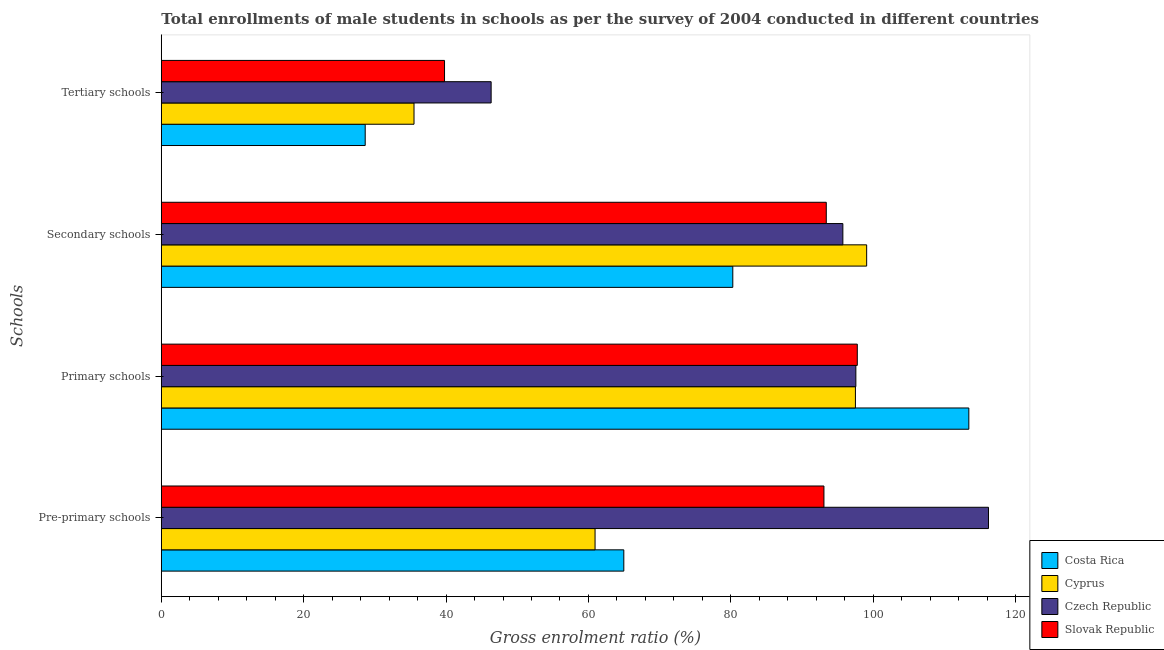Are the number of bars on each tick of the Y-axis equal?
Offer a terse response. Yes. How many bars are there on the 3rd tick from the top?
Provide a succinct answer. 4. What is the label of the 4th group of bars from the top?
Keep it short and to the point. Pre-primary schools. What is the gross enrolment ratio(male) in pre-primary schools in Cyprus?
Provide a short and direct response. 60.93. Across all countries, what is the maximum gross enrolment ratio(male) in tertiary schools?
Offer a very short reply. 46.33. Across all countries, what is the minimum gross enrolment ratio(male) in pre-primary schools?
Provide a short and direct response. 60.93. In which country was the gross enrolment ratio(male) in pre-primary schools minimum?
Your answer should be very brief. Cyprus. What is the total gross enrolment ratio(male) in tertiary schools in the graph?
Make the answer very short. 150.24. What is the difference between the gross enrolment ratio(male) in pre-primary schools in Cyprus and that in Slovak Republic?
Offer a very short reply. -32.15. What is the difference between the gross enrolment ratio(male) in secondary schools in Cyprus and the gross enrolment ratio(male) in primary schools in Czech Republic?
Your answer should be compact. 1.52. What is the average gross enrolment ratio(male) in secondary schools per country?
Give a very brief answer. 92.12. What is the difference between the gross enrolment ratio(male) in secondary schools and gross enrolment ratio(male) in pre-primary schools in Cyprus?
Provide a succinct answer. 38.15. What is the ratio of the gross enrolment ratio(male) in pre-primary schools in Czech Republic to that in Slovak Republic?
Your response must be concise. 1.25. Is the gross enrolment ratio(male) in primary schools in Slovak Republic less than that in Czech Republic?
Provide a succinct answer. No. What is the difference between the highest and the second highest gross enrolment ratio(male) in secondary schools?
Make the answer very short. 3.34. What is the difference between the highest and the lowest gross enrolment ratio(male) in tertiary schools?
Ensure brevity in your answer.  17.69. In how many countries, is the gross enrolment ratio(male) in pre-primary schools greater than the average gross enrolment ratio(male) in pre-primary schools taken over all countries?
Your answer should be compact. 2. Is the sum of the gross enrolment ratio(male) in secondary schools in Cyprus and Czech Republic greater than the maximum gross enrolment ratio(male) in pre-primary schools across all countries?
Your answer should be compact. Yes. What does the 2nd bar from the top in Tertiary schools represents?
Keep it short and to the point. Czech Republic. What does the 3rd bar from the bottom in Tertiary schools represents?
Make the answer very short. Czech Republic. Are all the bars in the graph horizontal?
Your answer should be compact. Yes. What is the difference between two consecutive major ticks on the X-axis?
Your answer should be very brief. 20. Are the values on the major ticks of X-axis written in scientific E-notation?
Offer a very short reply. No. How are the legend labels stacked?
Ensure brevity in your answer.  Vertical. What is the title of the graph?
Offer a terse response. Total enrollments of male students in schools as per the survey of 2004 conducted in different countries. What is the label or title of the X-axis?
Provide a short and direct response. Gross enrolment ratio (%). What is the label or title of the Y-axis?
Your answer should be very brief. Schools. What is the Gross enrolment ratio (%) in Costa Rica in Pre-primary schools?
Your answer should be very brief. 64.96. What is the Gross enrolment ratio (%) in Cyprus in Pre-primary schools?
Give a very brief answer. 60.93. What is the Gross enrolment ratio (%) in Czech Republic in Pre-primary schools?
Make the answer very short. 116.19. What is the Gross enrolment ratio (%) in Slovak Republic in Pre-primary schools?
Make the answer very short. 93.08. What is the Gross enrolment ratio (%) of Costa Rica in Primary schools?
Make the answer very short. 113.43. What is the Gross enrolment ratio (%) in Cyprus in Primary schools?
Ensure brevity in your answer.  97.5. What is the Gross enrolment ratio (%) in Czech Republic in Primary schools?
Your response must be concise. 97.56. What is the Gross enrolment ratio (%) in Slovak Republic in Primary schools?
Provide a short and direct response. 97.76. What is the Gross enrolment ratio (%) of Costa Rica in Secondary schools?
Your answer should be very brief. 80.27. What is the Gross enrolment ratio (%) of Cyprus in Secondary schools?
Provide a short and direct response. 99.08. What is the Gross enrolment ratio (%) in Czech Republic in Secondary schools?
Make the answer very short. 95.73. What is the Gross enrolment ratio (%) in Slovak Republic in Secondary schools?
Offer a very short reply. 93.41. What is the Gross enrolment ratio (%) in Costa Rica in Tertiary schools?
Make the answer very short. 28.64. What is the Gross enrolment ratio (%) of Cyprus in Tertiary schools?
Give a very brief answer. 35.49. What is the Gross enrolment ratio (%) of Czech Republic in Tertiary schools?
Provide a short and direct response. 46.33. What is the Gross enrolment ratio (%) of Slovak Republic in Tertiary schools?
Make the answer very short. 39.78. Across all Schools, what is the maximum Gross enrolment ratio (%) in Costa Rica?
Provide a short and direct response. 113.43. Across all Schools, what is the maximum Gross enrolment ratio (%) in Cyprus?
Offer a very short reply. 99.08. Across all Schools, what is the maximum Gross enrolment ratio (%) in Czech Republic?
Give a very brief answer. 116.19. Across all Schools, what is the maximum Gross enrolment ratio (%) of Slovak Republic?
Your response must be concise. 97.76. Across all Schools, what is the minimum Gross enrolment ratio (%) in Costa Rica?
Offer a terse response. 28.64. Across all Schools, what is the minimum Gross enrolment ratio (%) of Cyprus?
Provide a succinct answer. 35.49. Across all Schools, what is the minimum Gross enrolment ratio (%) of Czech Republic?
Offer a very short reply. 46.33. Across all Schools, what is the minimum Gross enrolment ratio (%) in Slovak Republic?
Provide a short and direct response. 39.78. What is the total Gross enrolment ratio (%) of Costa Rica in the graph?
Offer a terse response. 287.31. What is the total Gross enrolment ratio (%) in Cyprus in the graph?
Provide a short and direct response. 293. What is the total Gross enrolment ratio (%) in Czech Republic in the graph?
Provide a succinct answer. 355.81. What is the total Gross enrolment ratio (%) in Slovak Republic in the graph?
Offer a terse response. 324.02. What is the difference between the Gross enrolment ratio (%) of Costa Rica in Pre-primary schools and that in Primary schools?
Give a very brief answer. -48.46. What is the difference between the Gross enrolment ratio (%) of Cyprus in Pre-primary schools and that in Primary schools?
Your answer should be very brief. -36.57. What is the difference between the Gross enrolment ratio (%) in Czech Republic in Pre-primary schools and that in Primary schools?
Offer a terse response. 18.63. What is the difference between the Gross enrolment ratio (%) of Slovak Republic in Pre-primary schools and that in Primary schools?
Provide a short and direct response. -4.68. What is the difference between the Gross enrolment ratio (%) of Costa Rica in Pre-primary schools and that in Secondary schools?
Give a very brief answer. -15.31. What is the difference between the Gross enrolment ratio (%) in Cyprus in Pre-primary schools and that in Secondary schools?
Your answer should be very brief. -38.15. What is the difference between the Gross enrolment ratio (%) of Czech Republic in Pre-primary schools and that in Secondary schools?
Provide a succinct answer. 20.46. What is the difference between the Gross enrolment ratio (%) of Slovak Republic in Pre-primary schools and that in Secondary schools?
Make the answer very short. -0.33. What is the difference between the Gross enrolment ratio (%) in Costa Rica in Pre-primary schools and that in Tertiary schools?
Offer a very short reply. 36.33. What is the difference between the Gross enrolment ratio (%) of Cyprus in Pre-primary schools and that in Tertiary schools?
Provide a succinct answer. 25.43. What is the difference between the Gross enrolment ratio (%) in Czech Republic in Pre-primary schools and that in Tertiary schools?
Offer a very short reply. 69.86. What is the difference between the Gross enrolment ratio (%) in Slovak Republic in Pre-primary schools and that in Tertiary schools?
Provide a short and direct response. 53.29. What is the difference between the Gross enrolment ratio (%) in Costa Rica in Primary schools and that in Secondary schools?
Your answer should be compact. 33.15. What is the difference between the Gross enrolment ratio (%) in Cyprus in Primary schools and that in Secondary schools?
Provide a succinct answer. -1.58. What is the difference between the Gross enrolment ratio (%) in Czech Republic in Primary schools and that in Secondary schools?
Offer a terse response. 1.83. What is the difference between the Gross enrolment ratio (%) in Slovak Republic in Primary schools and that in Secondary schools?
Make the answer very short. 4.36. What is the difference between the Gross enrolment ratio (%) in Costa Rica in Primary schools and that in Tertiary schools?
Ensure brevity in your answer.  84.79. What is the difference between the Gross enrolment ratio (%) in Cyprus in Primary schools and that in Tertiary schools?
Keep it short and to the point. 62. What is the difference between the Gross enrolment ratio (%) of Czech Republic in Primary schools and that in Tertiary schools?
Provide a short and direct response. 51.23. What is the difference between the Gross enrolment ratio (%) in Slovak Republic in Primary schools and that in Tertiary schools?
Your response must be concise. 57.98. What is the difference between the Gross enrolment ratio (%) of Costa Rica in Secondary schools and that in Tertiary schools?
Ensure brevity in your answer.  51.63. What is the difference between the Gross enrolment ratio (%) in Cyprus in Secondary schools and that in Tertiary schools?
Keep it short and to the point. 63.58. What is the difference between the Gross enrolment ratio (%) of Czech Republic in Secondary schools and that in Tertiary schools?
Your answer should be compact. 49.4. What is the difference between the Gross enrolment ratio (%) in Slovak Republic in Secondary schools and that in Tertiary schools?
Ensure brevity in your answer.  53.62. What is the difference between the Gross enrolment ratio (%) of Costa Rica in Pre-primary schools and the Gross enrolment ratio (%) of Cyprus in Primary schools?
Your answer should be very brief. -32.53. What is the difference between the Gross enrolment ratio (%) in Costa Rica in Pre-primary schools and the Gross enrolment ratio (%) in Czech Republic in Primary schools?
Ensure brevity in your answer.  -32.59. What is the difference between the Gross enrolment ratio (%) in Costa Rica in Pre-primary schools and the Gross enrolment ratio (%) in Slovak Republic in Primary schools?
Provide a succinct answer. -32.8. What is the difference between the Gross enrolment ratio (%) of Cyprus in Pre-primary schools and the Gross enrolment ratio (%) of Czech Republic in Primary schools?
Your answer should be very brief. -36.63. What is the difference between the Gross enrolment ratio (%) in Cyprus in Pre-primary schools and the Gross enrolment ratio (%) in Slovak Republic in Primary schools?
Your response must be concise. -36.83. What is the difference between the Gross enrolment ratio (%) in Czech Republic in Pre-primary schools and the Gross enrolment ratio (%) in Slovak Republic in Primary schools?
Your response must be concise. 18.43. What is the difference between the Gross enrolment ratio (%) in Costa Rica in Pre-primary schools and the Gross enrolment ratio (%) in Cyprus in Secondary schools?
Ensure brevity in your answer.  -34.11. What is the difference between the Gross enrolment ratio (%) of Costa Rica in Pre-primary schools and the Gross enrolment ratio (%) of Czech Republic in Secondary schools?
Provide a succinct answer. -30.77. What is the difference between the Gross enrolment ratio (%) of Costa Rica in Pre-primary schools and the Gross enrolment ratio (%) of Slovak Republic in Secondary schools?
Your answer should be very brief. -28.44. What is the difference between the Gross enrolment ratio (%) of Cyprus in Pre-primary schools and the Gross enrolment ratio (%) of Czech Republic in Secondary schools?
Your answer should be compact. -34.81. What is the difference between the Gross enrolment ratio (%) in Cyprus in Pre-primary schools and the Gross enrolment ratio (%) in Slovak Republic in Secondary schools?
Your response must be concise. -32.48. What is the difference between the Gross enrolment ratio (%) of Czech Republic in Pre-primary schools and the Gross enrolment ratio (%) of Slovak Republic in Secondary schools?
Make the answer very short. 22.78. What is the difference between the Gross enrolment ratio (%) in Costa Rica in Pre-primary schools and the Gross enrolment ratio (%) in Cyprus in Tertiary schools?
Provide a succinct answer. 29.47. What is the difference between the Gross enrolment ratio (%) in Costa Rica in Pre-primary schools and the Gross enrolment ratio (%) in Czech Republic in Tertiary schools?
Your response must be concise. 18.64. What is the difference between the Gross enrolment ratio (%) of Costa Rica in Pre-primary schools and the Gross enrolment ratio (%) of Slovak Republic in Tertiary schools?
Provide a succinct answer. 25.18. What is the difference between the Gross enrolment ratio (%) of Cyprus in Pre-primary schools and the Gross enrolment ratio (%) of Czech Republic in Tertiary schools?
Give a very brief answer. 14.6. What is the difference between the Gross enrolment ratio (%) in Cyprus in Pre-primary schools and the Gross enrolment ratio (%) in Slovak Republic in Tertiary schools?
Your answer should be compact. 21.14. What is the difference between the Gross enrolment ratio (%) of Czech Republic in Pre-primary schools and the Gross enrolment ratio (%) of Slovak Republic in Tertiary schools?
Provide a succinct answer. 76.41. What is the difference between the Gross enrolment ratio (%) in Costa Rica in Primary schools and the Gross enrolment ratio (%) in Cyprus in Secondary schools?
Ensure brevity in your answer.  14.35. What is the difference between the Gross enrolment ratio (%) in Costa Rica in Primary schools and the Gross enrolment ratio (%) in Czech Republic in Secondary schools?
Provide a succinct answer. 17.7. What is the difference between the Gross enrolment ratio (%) in Costa Rica in Primary schools and the Gross enrolment ratio (%) in Slovak Republic in Secondary schools?
Offer a very short reply. 20.02. What is the difference between the Gross enrolment ratio (%) in Cyprus in Primary schools and the Gross enrolment ratio (%) in Czech Republic in Secondary schools?
Your answer should be very brief. 1.77. What is the difference between the Gross enrolment ratio (%) in Cyprus in Primary schools and the Gross enrolment ratio (%) in Slovak Republic in Secondary schools?
Make the answer very short. 4.09. What is the difference between the Gross enrolment ratio (%) in Czech Republic in Primary schools and the Gross enrolment ratio (%) in Slovak Republic in Secondary schools?
Keep it short and to the point. 4.15. What is the difference between the Gross enrolment ratio (%) in Costa Rica in Primary schools and the Gross enrolment ratio (%) in Cyprus in Tertiary schools?
Keep it short and to the point. 77.93. What is the difference between the Gross enrolment ratio (%) in Costa Rica in Primary schools and the Gross enrolment ratio (%) in Czech Republic in Tertiary schools?
Offer a terse response. 67.1. What is the difference between the Gross enrolment ratio (%) in Costa Rica in Primary schools and the Gross enrolment ratio (%) in Slovak Republic in Tertiary schools?
Your answer should be compact. 73.65. What is the difference between the Gross enrolment ratio (%) in Cyprus in Primary schools and the Gross enrolment ratio (%) in Czech Republic in Tertiary schools?
Your response must be concise. 51.17. What is the difference between the Gross enrolment ratio (%) in Cyprus in Primary schools and the Gross enrolment ratio (%) in Slovak Republic in Tertiary schools?
Offer a very short reply. 57.72. What is the difference between the Gross enrolment ratio (%) of Czech Republic in Primary schools and the Gross enrolment ratio (%) of Slovak Republic in Tertiary schools?
Make the answer very short. 57.78. What is the difference between the Gross enrolment ratio (%) of Costa Rica in Secondary schools and the Gross enrolment ratio (%) of Cyprus in Tertiary schools?
Offer a very short reply. 44.78. What is the difference between the Gross enrolment ratio (%) in Costa Rica in Secondary schools and the Gross enrolment ratio (%) in Czech Republic in Tertiary schools?
Give a very brief answer. 33.95. What is the difference between the Gross enrolment ratio (%) of Costa Rica in Secondary schools and the Gross enrolment ratio (%) of Slovak Republic in Tertiary schools?
Make the answer very short. 40.49. What is the difference between the Gross enrolment ratio (%) in Cyprus in Secondary schools and the Gross enrolment ratio (%) in Czech Republic in Tertiary schools?
Offer a terse response. 52.75. What is the difference between the Gross enrolment ratio (%) of Cyprus in Secondary schools and the Gross enrolment ratio (%) of Slovak Republic in Tertiary schools?
Your answer should be compact. 59.3. What is the difference between the Gross enrolment ratio (%) of Czech Republic in Secondary schools and the Gross enrolment ratio (%) of Slovak Republic in Tertiary schools?
Offer a very short reply. 55.95. What is the average Gross enrolment ratio (%) of Costa Rica per Schools?
Provide a short and direct response. 71.83. What is the average Gross enrolment ratio (%) of Cyprus per Schools?
Offer a very short reply. 73.25. What is the average Gross enrolment ratio (%) of Czech Republic per Schools?
Offer a terse response. 88.95. What is the average Gross enrolment ratio (%) in Slovak Republic per Schools?
Ensure brevity in your answer.  81.01. What is the difference between the Gross enrolment ratio (%) in Costa Rica and Gross enrolment ratio (%) in Cyprus in Pre-primary schools?
Give a very brief answer. 4.04. What is the difference between the Gross enrolment ratio (%) of Costa Rica and Gross enrolment ratio (%) of Czech Republic in Pre-primary schools?
Your answer should be compact. -51.22. What is the difference between the Gross enrolment ratio (%) of Costa Rica and Gross enrolment ratio (%) of Slovak Republic in Pre-primary schools?
Ensure brevity in your answer.  -28.11. What is the difference between the Gross enrolment ratio (%) in Cyprus and Gross enrolment ratio (%) in Czech Republic in Pre-primary schools?
Your answer should be compact. -55.26. What is the difference between the Gross enrolment ratio (%) in Cyprus and Gross enrolment ratio (%) in Slovak Republic in Pre-primary schools?
Make the answer very short. -32.15. What is the difference between the Gross enrolment ratio (%) in Czech Republic and Gross enrolment ratio (%) in Slovak Republic in Pre-primary schools?
Give a very brief answer. 23.11. What is the difference between the Gross enrolment ratio (%) in Costa Rica and Gross enrolment ratio (%) in Cyprus in Primary schools?
Offer a very short reply. 15.93. What is the difference between the Gross enrolment ratio (%) in Costa Rica and Gross enrolment ratio (%) in Czech Republic in Primary schools?
Offer a terse response. 15.87. What is the difference between the Gross enrolment ratio (%) of Costa Rica and Gross enrolment ratio (%) of Slovak Republic in Primary schools?
Your answer should be compact. 15.67. What is the difference between the Gross enrolment ratio (%) of Cyprus and Gross enrolment ratio (%) of Czech Republic in Primary schools?
Provide a short and direct response. -0.06. What is the difference between the Gross enrolment ratio (%) in Cyprus and Gross enrolment ratio (%) in Slovak Republic in Primary schools?
Ensure brevity in your answer.  -0.26. What is the difference between the Gross enrolment ratio (%) of Czech Republic and Gross enrolment ratio (%) of Slovak Republic in Primary schools?
Offer a very short reply. -0.2. What is the difference between the Gross enrolment ratio (%) of Costa Rica and Gross enrolment ratio (%) of Cyprus in Secondary schools?
Provide a succinct answer. -18.8. What is the difference between the Gross enrolment ratio (%) of Costa Rica and Gross enrolment ratio (%) of Czech Republic in Secondary schools?
Your answer should be compact. -15.46. What is the difference between the Gross enrolment ratio (%) of Costa Rica and Gross enrolment ratio (%) of Slovak Republic in Secondary schools?
Your answer should be compact. -13.13. What is the difference between the Gross enrolment ratio (%) of Cyprus and Gross enrolment ratio (%) of Czech Republic in Secondary schools?
Provide a succinct answer. 3.34. What is the difference between the Gross enrolment ratio (%) in Cyprus and Gross enrolment ratio (%) in Slovak Republic in Secondary schools?
Make the answer very short. 5.67. What is the difference between the Gross enrolment ratio (%) of Czech Republic and Gross enrolment ratio (%) of Slovak Republic in Secondary schools?
Your answer should be very brief. 2.33. What is the difference between the Gross enrolment ratio (%) of Costa Rica and Gross enrolment ratio (%) of Cyprus in Tertiary schools?
Your answer should be compact. -6.86. What is the difference between the Gross enrolment ratio (%) of Costa Rica and Gross enrolment ratio (%) of Czech Republic in Tertiary schools?
Ensure brevity in your answer.  -17.69. What is the difference between the Gross enrolment ratio (%) of Costa Rica and Gross enrolment ratio (%) of Slovak Republic in Tertiary schools?
Give a very brief answer. -11.14. What is the difference between the Gross enrolment ratio (%) in Cyprus and Gross enrolment ratio (%) in Czech Republic in Tertiary schools?
Your answer should be compact. -10.83. What is the difference between the Gross enrolment ratio (%) of Cyprus and Gross enrolment ratio (%) of Slovak Republic in Tertiary schools?
Offer a terse response. -4.29. What is the difference between the Gross enrolment ratio (%) of Czech Republic and Gross enrolment ratio (%) of Slovak Republic in Tertiary schools?
Your response must be concise. 6.55. What is the ratio of the Gross enrolment ratio (%) in Costa Rica in Pre-primary schools to that in Primary schools?
Provide a succinct answer. 0.57. What is the ratio of the Gross enrolment ratio (%) of Cyprus in Pre-primary schools to that in Primary schools?
Provide a short and direct response. 0.62. What is the ratio of the Gross enrolment ratio (%) of Czech Republic in Pre-primary schools to that in Primary schools?
Your answer should be compact. 1.19. What is the ratio of the Gross enrolment ratio (%) of Slovak Republic in Pre-primary schools to that in Primary schools?
Make the answer very short. 0.95. What is the ratio of the Gross enrolment ratio (%) of Costa Rica in Pre-primary schools to that in Secondary schools?
Make the answer very short. 0.81. What is the ratio of the Gross enrolment ratio (%) in Cyprus in Pre-primary schools to that in Secondary schools?
Give a very brief answer. 0.61. What is the ratio of the Gross enrolment ratio (%) in Czech Republic in Pre-primary schools to that in Secondary schools?
Your answer should be very brief. 1.21. What is the ratio of the Gross enrolment ratio (%) in Slovak Republic in Pre-primary schools to that in Secondary schools?
Provide a succinct answer. 1. What is the ratio of the Gross enrolment ratio (%) in Costa Rica in Pre-primary schools to that in Tertiary schools?
Your answer should be very brief. 2.27. What is the ratio of the Gross enrolment ratio (%) of Cyprus in Pre-primary schools to that in Tertiary schools?
Your answer should be very brief. 1.72. What is the ratio of the Gross enrolment ratio (%) of Czech Republic in Pre-primary schools to that in Tertiary schools?
Offer a terse response. 2.51. What is the ratio of the Gross enrolment ratio (%) of Slovak Republic in Pre-primary schools to that in Tertiary schools?
Your answer should be very brief. 2.34. What is the ratio of the Gross enrolment ratio (%) in Costa Rica in Primary schools to that in Secondary schools?
Offer a very short reply. 1.41. What is the ratio of the Gross enrolment ratio (%) in Cyprus in Primary schools to that in Secondary schools?
Your answer should be compact. 0.98. What is the ratio of the Gross enrolment ratio (%) of Czech Republic in Primary schools to that in Secondary schools?
Offer a very short reply. 1.02. What is the ratio of the Gross enrolment ratio (%) in Slovak Republic in Primary schools to that in Secondary schools?
Ensure brevity in your answer.  1.05. What is the ratio of the Gross enrolment ratio (%) of Costa Rica in Primary schools to that in Tertiary schools?
Provide a succinct answer. 3.96. What is the ratio of the Gross enrolment ratio (%) of Cyprus in Primary schools to that in Tertiary schools?
Provide a succinct answer. 2.75. What is the ratio of the Gross enrolment ratio (%) of Czech Republic in Primary schools to that in Tertiary schools?
Make the answer very short. 2.11. What is the ratio of the Gross enrolment ratio (%) in Slovak Republic in Primary schools to that in Tertiary schools?
Ensure brevity in your answer.  2.46. What is the ratio of the Gross enrolment ratio (%) in Costa Rica in Secondary schools to that in Tertiary schools?
Keep it short and to the point. 2.8. What is the ratio of the Gross enrolment ratio (%) in Cyprus in Secondary schools to that in Tertiary schools?
Offer a very short reply. 2.79. What is the ratio of the Gross enrolment ratio (%) of Czech Republic in Secondary schools to that in Tertiary schools?
Provide a short and direct response. 2.07. What is the ratio of the Gross enrolment ratio (%) in Slovak Republic in Secondary schools to that in Tertiary schools?
Your answer should be very brief. 2.35. What is the difference between the highest and the second highest Gross enrolment ratio (%) of Costa Rica?
Ensure brevity in your answer.  33.15. What is the difference between the highest and the second highest Gross enrolment ratio (%) in Cyprus?
Keep it short and to the point. 1.58. What is the difference between the highest and the second highest Gross enrolment ratio (%) in Czech Republic?
Provide a short and direct response. 18.63. What is the difference between the highest and the second highest Gross enrolment ratio (%) in Slovak Republic?
Make the answer very short. 4.36. What is the difference between the highest and the lowest Gross enrolment ratio (%) in Costa Rica?
Ensure brevity in your answer.  84.79. What is the difference between the highest and the lowest Gross enrolment ratio (%) in Cyprus?
Provide a short and direct response. 63.58. What is the difference between the highest and the lowest Gross enrolment ratio (%) of Czech Republic?
Make the answer very short. 69.86. What is the difference between the highest and the lowest Gross enrolment ratio (%) in Slovak Republic?
Your response must be concise. 57.98. 